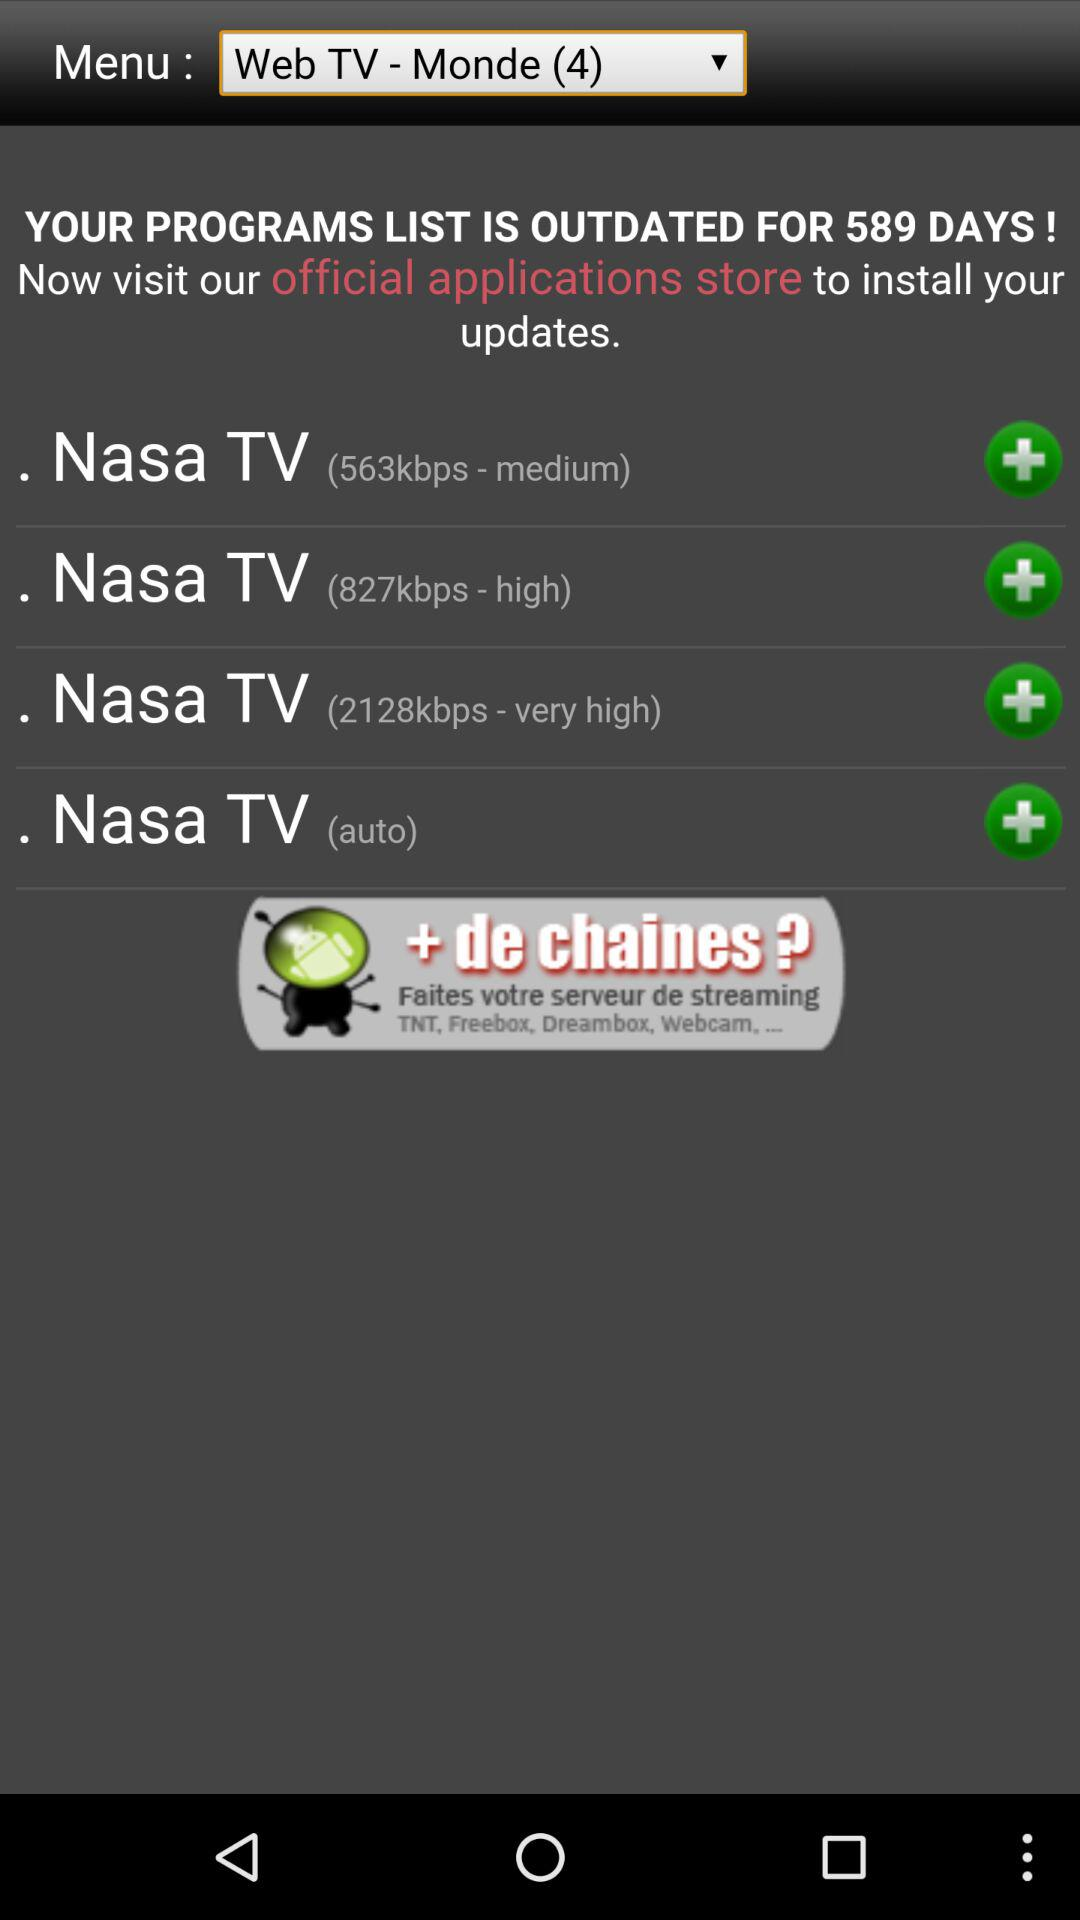What is the selected menu? The selected menu is "Web TV - Monde (4)". 